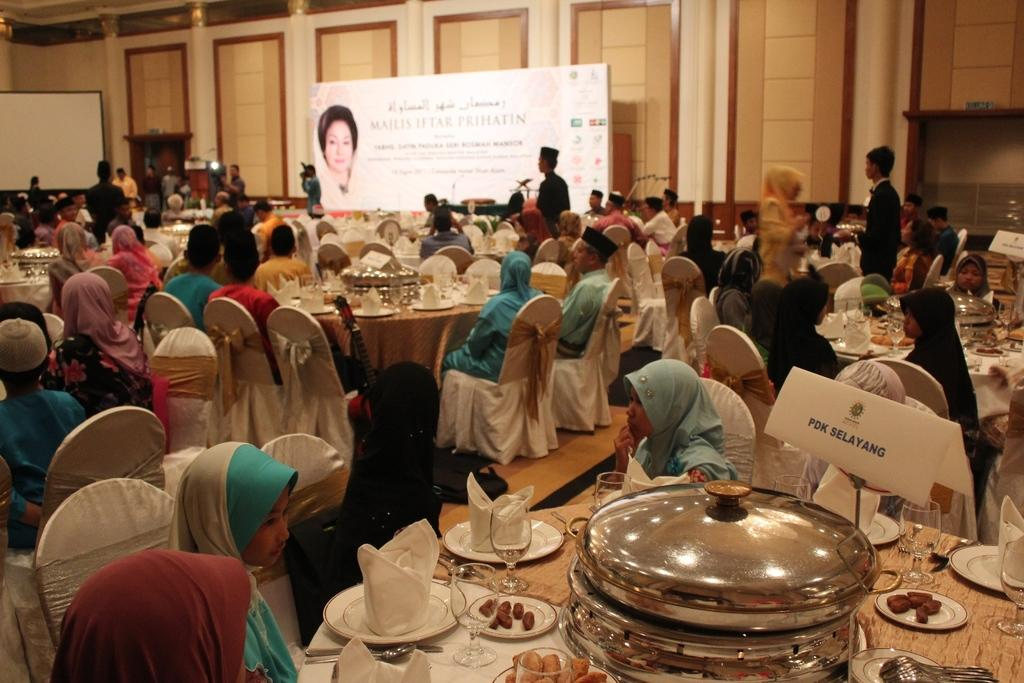What is happening in the image involving the group of people? The people in the image are sitting on chairs and having food. Can you describe the location of the hoarding in the image? The hoarding is located in the top center of the room. How many babies are crawling in the garden in the image? There is no garden or babies present in the image. What type of rings are the people wearing while eating in the image? There is no mention of rings in the image; the people are simply having food while sitting on chairs. 